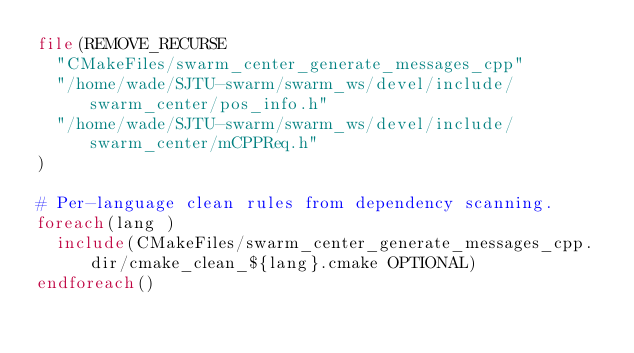<code> <loc_0><loc_0><loc_500><loc_500><_CMake_>file(REMOVE_RECURSE
  "CMakeFiles/swarm_center_generate_messages_cpp"
  "/home/wade/SJTU-swarm/swarm_ws/devel/include/swarm_center/pos_info.h"
  "/home/wade/SJTU-swarm/swarm_ws/devel/include/swarm_center/mCPPReq.h"
)

# Per-language clean rules from dependency scanning.
foreach(lang )
  include(CMakeFiles/swarm_center_generate_messages_cpp.dir/cmake_clean_${lang}.cmake OPTIONAL)
endforeach()
</code> 